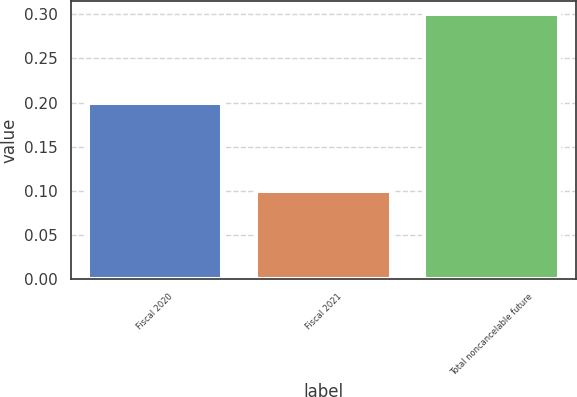Convert chart to OTSL. <chart><loc_0><loc_0><loc_500><loc_500><bar_chart><fcel>Fiscal 2020<fcel>Fiscal 2021<fcel>Total noncancelable future<nl><fcel>0.2<fcel>0.1<fcel>0.3<nl></chart> 